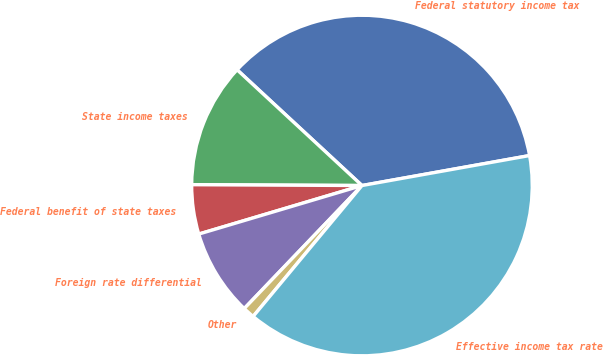Convert chart to OTSL. <chart><loc_0><loc_0><loc_500><loc_500><pie_chart><fcel>Federal statutory income tax<fcel>State income taxes<fcel>Federal benefit of state taxes<fcel>Foreign rate differential<fcel>Other<fcel>Effective income tax rate<nl><fcel>35.29%<fcel>11.82%<fcel>4.68%<fcel>8.25%<fcel>1.11%<fcel>38.86%<nl></chart> 